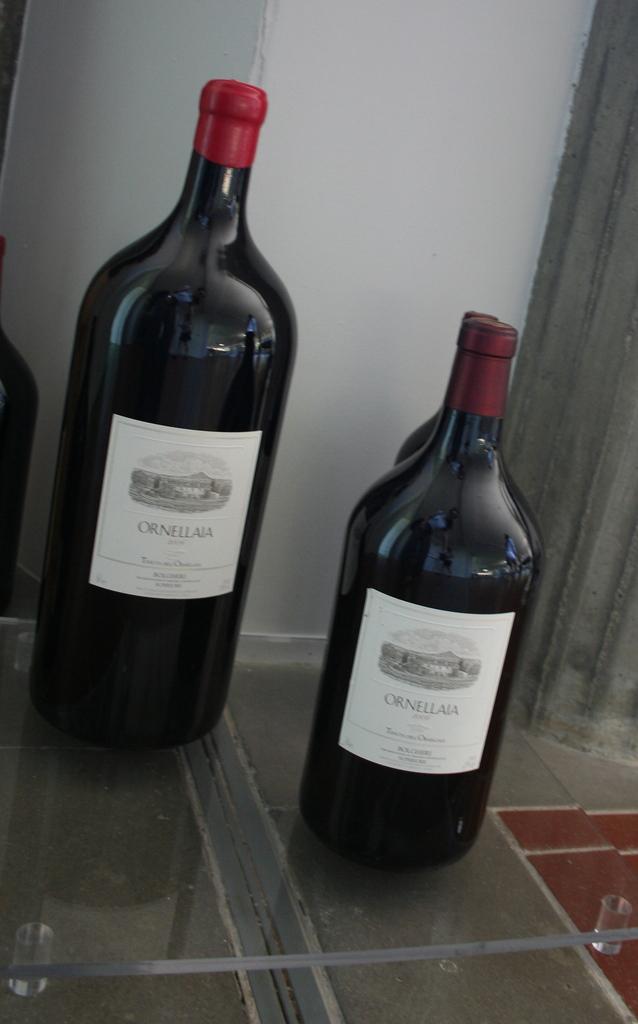What brand of alcohol is this?
Offer a very short reply. Ornellaia. 